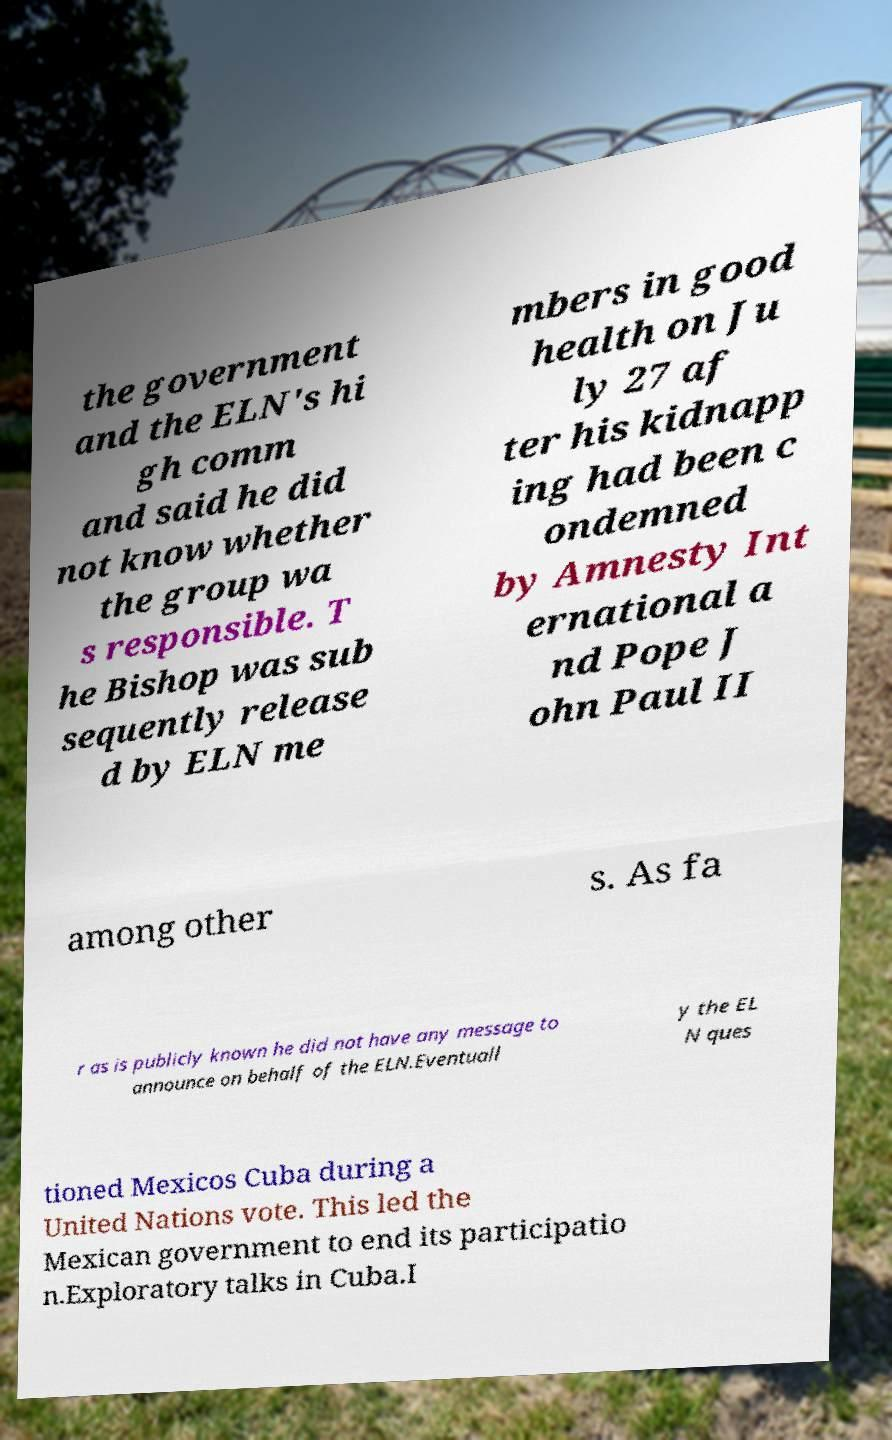Can you accurately transcribe the text from the provided image for me? the government and the ELN's hi gh comm and said he did not know whether the group wa s responsible. T he Bishop was sub sequently release d by ELN me mbers in good health on Ju ly 27 af ter his kidnapp ing had been c ondemned by Amnesty Int ernational a nd Pope J ohn Paul II among other s. As fa r as is publicly known he did not have any message to announce on behalf of the ELN.Eventuall y the EL N ques tioned Mexicos Cuba during a United Nations vote. This led the Mexican government to end its participatio n.Exploratory talks in Cuba.I 